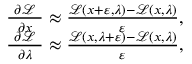<formula> <loc_0><loc_0><loc_500><loc_500>{ \begin{array} { r } { { \frac { \ \partial { \mathcal { L } } \ } { \partial x } } \approx { \frac { { \mathcal { L } } ( x + \varepsilon , \lambda ) - { \mathcal { L } } ( x , \lambda ) } { \varepsilon } } , } \\ { { \frac { \ \partial { \mathcal { L } } \ } { \partial \lambda } } \approx { \frac { { \mathcal { L } } ( x , \lambda + \varepsilon ) - { \mathcal { L } } ( x , \lambda ) } { \varepsilon } } , } \end{array} }</formula> 